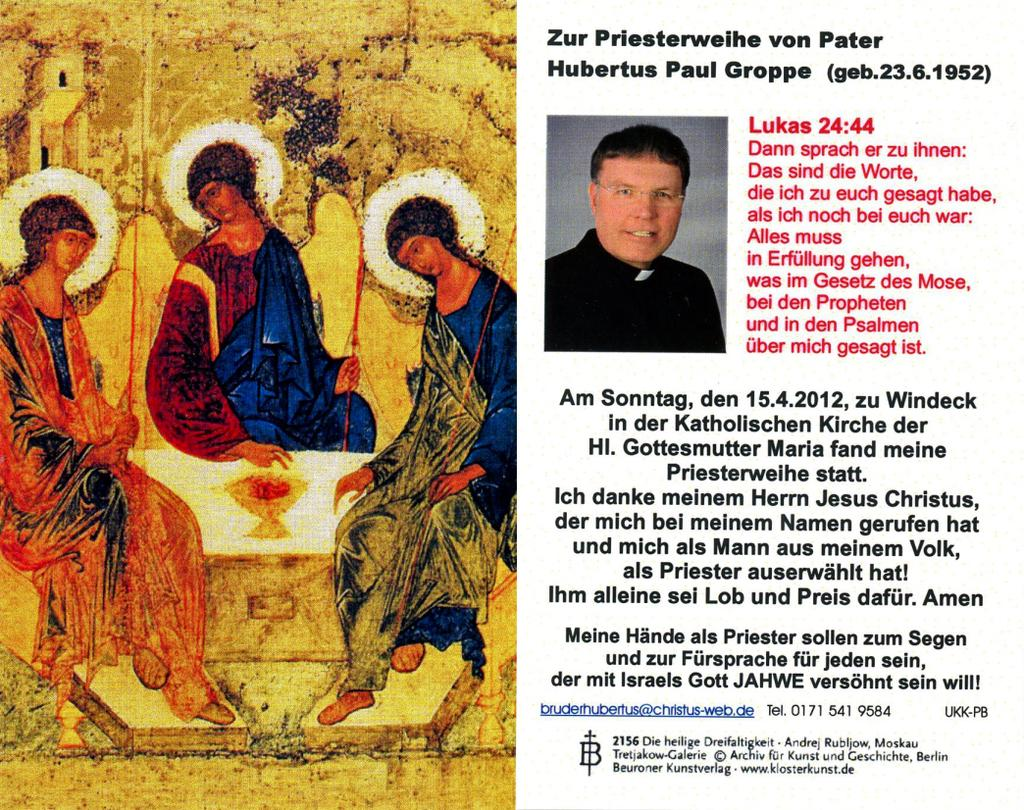What is the main subject in the image? There is a poster in the image. What type of music can be heard playing from the plough in the image? There is no plough or music present in the image; it only features a poster. 